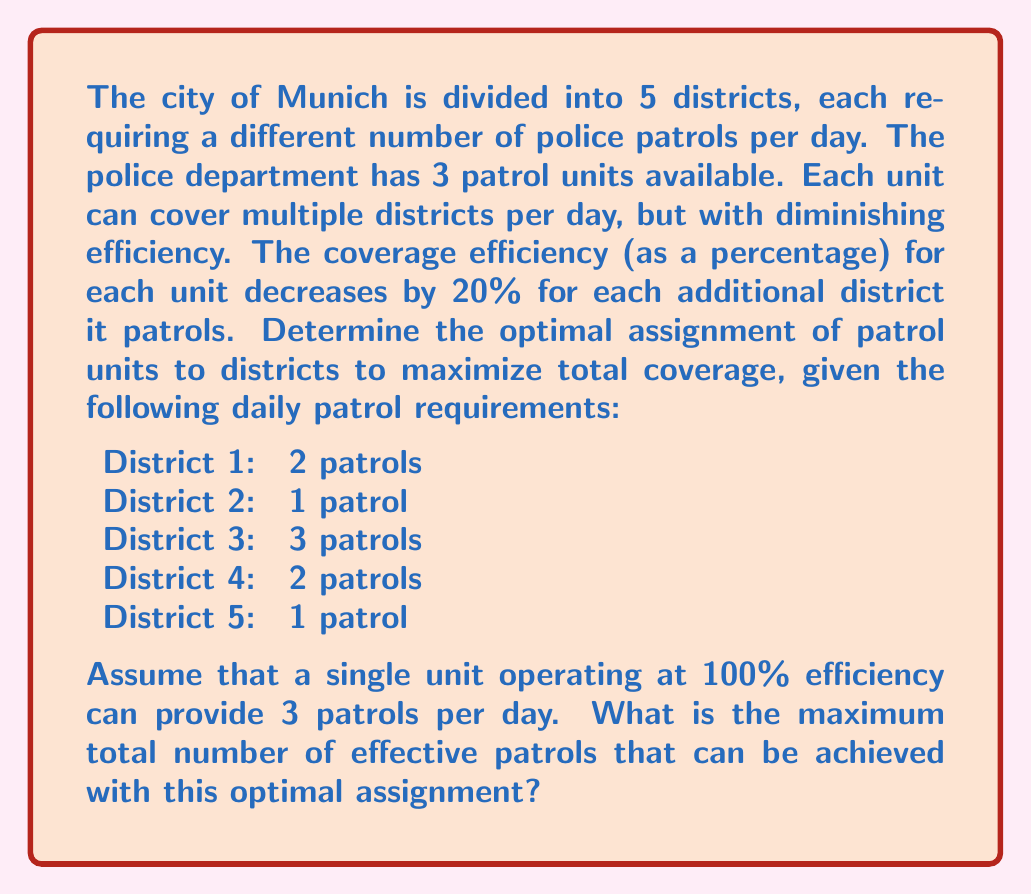Provide a solution to this math problem. To solve this problem, we need to consider the efficiency decrease and optimize the assignment of patrol units. Let's approach this step-by-step:

1) First, let's calculate the efficiency for units covering multiple districts:
   - 1 district: 100% efficiency
   - 2 districts: 80% efficiency
   - 3 districts: 60% efficiency
   - 4 districts: 40% efficiency
   - 5 districts: 20% efficiency

2) Given that a unit at 100% efficiency can provide 3 patrols, we can calculate the number of patrols for each scenario:
   - 1 district: $3 \times 100\% = 3$ patrols
   - 2 districts: $3 \times 80\% = 2.4$ patrols
   - 3 districts: $3 \times 60\% = 1.8$ patrols
   - 4 districts: $3 \times 40\% = 1.2$ patrols
   - 5 districts: $3 \times 20\% = 0.6$ patrols

3) Now, let's consider the optimal assignment:
   - Unit 1: Assign to Districts 1 and 4 (2 + 2 = 4 patrols required)
   - Unit 2: Assign to District 3 (3 patrols required)
   - Unit 3: Assign to Districts 2 and 5 (1 + 1 = 2 patrols required)

4) Calculate the effective patrols for each unit:
   - Unit 1 (2 districts): $3 \times 80\% = 2.4$ patrols
   - Unit 2 (1 district): $3 \times 100\% = 3$ patrols
   - Unit 3 (2 districts): $3 \times 80\% = 2.4$ patrols

5) Sum up the total effective patrols:
   $$ \text{Total effective patrols} = 2.4 + 3 + 2.4 = 7.8 $$

This assignment maximizes the coverage while meeting the requirements of each district.
Answer: The maximum total number of effective patrols that can be achieved with the optimal assignment is 7.8. 